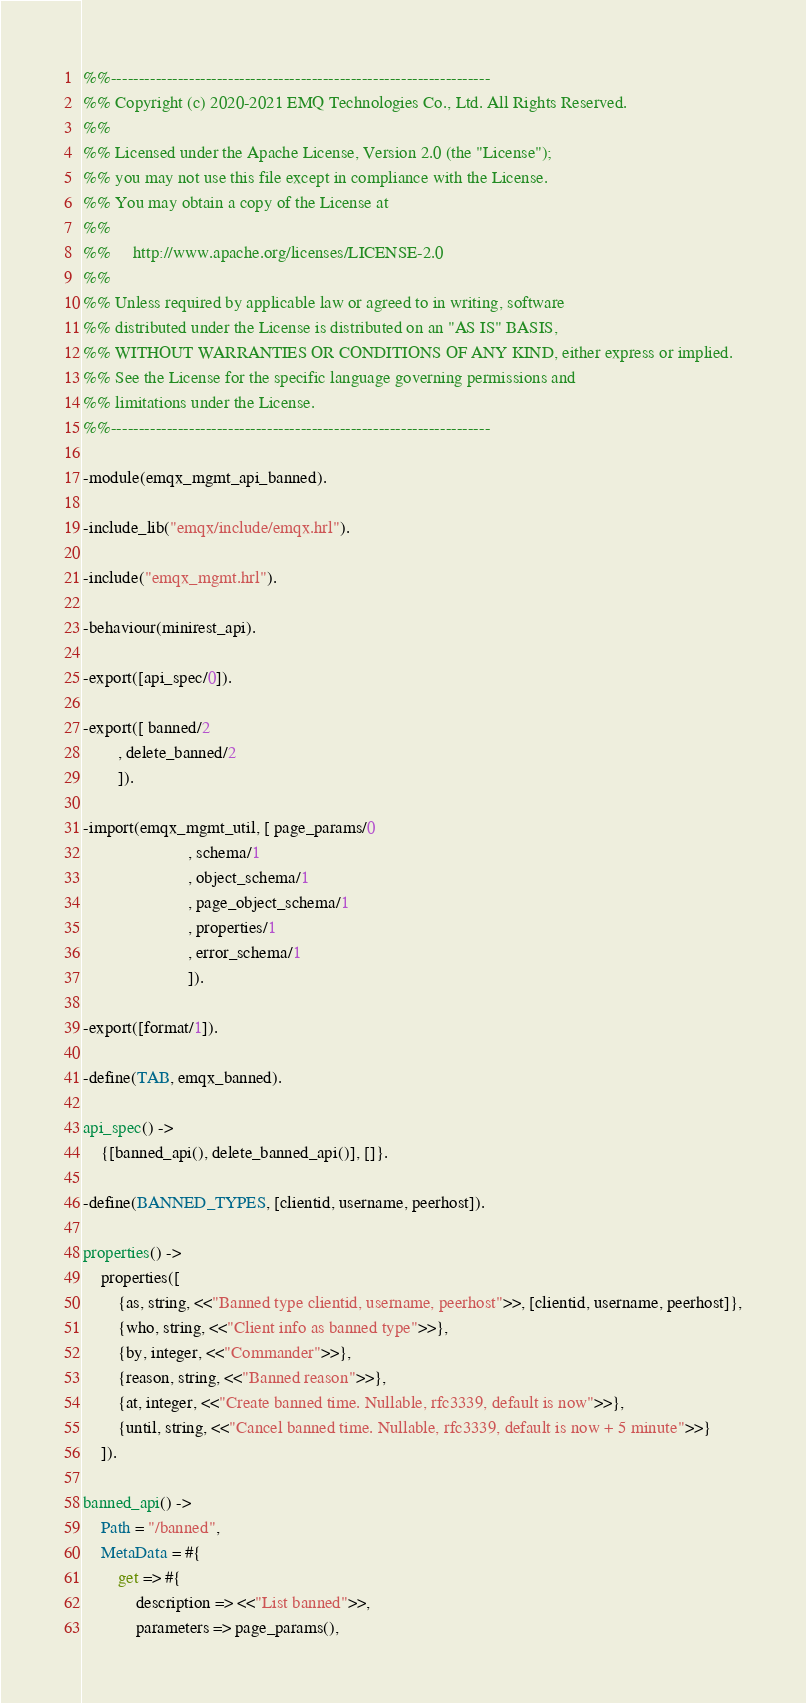<code> <loc_0><loc_0><loc_500><loc_500><_Erlang_>%%--------------------------------------------------------------------
%% Copyright (c) 2020-2021 EMQ Technologies Co., Ltd. All Rights Reserved.
%%
%% Licensed under the Apache License, Version 2.0 (the "License");
%% you may not use this file except in compliance with the License.
%% You may obtain a copy of the License at
%%
%%     http://www.apache.org/licenses/LICENSE-2.0
%%
%% Unless required by applicable law or agreed to in writing, software
%% distributed under the License is distributed on an "AS IS" BASIS,
%% WITHOUT WARRANTIES OR CONDITIONS OF ANY KIND, either express or implied.
%% See the License for the specific language governing permissions and
%% limitations under the License.
%%--------------------------------------------------------------------

-module(emqx_mgmt_api_banned).

-include_lib("emqx/include/emqx.hrl").

-include("emqx_mgmt.hrl").

-behaviour(minirest_api).

-export([api_spec/0]).

-export([ banned/2
        , delete_banned/2
        ]).

-import(emqx_mgmt_util, [ page_params/0
                        , schema/1
                        , object_schema/1
                        , page_object_schema/1
                        , properties/1
                        , error_schema/1
                        ]).

-export([format/1]).

-define(TAB, emqx_banned).

api_spec() ->
    {[banned_api(), delete_banned_api()], []}.

-define(BANNED_TYPES, [clientid, username, peerhost]).

properties() ->
    properties([
        {as, string, <<"Banned type clientid, username, peerhost">>, [clientid, username, peerhost]},
        {who, string, <<"Client info as banned type">>},
        {by, integer, <<"Commander">>},
        {reason, string, <<"Banned reason">>},
        {at, integer, <<"Create banned time. Nullable, rfc3339, default is now">>},
        {until, string, <<"Cancel banned time. Nullable, rfc3339, default is now + 5 minute">>}
    ]).

banned_api() ->
    Path = "/banned",
    MetaData = #{
        get => #{
            description => <<"List banned">>,
            parameters => page_params(),</code> 